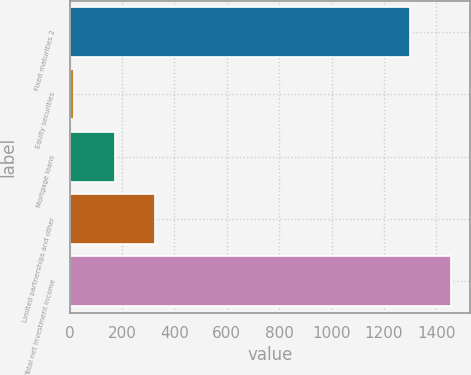<chart> <loc_0><loc_0><loc_500><loc_500><bar_chart><fcel>Fixed maturities 2<fcel>Equity securities<fcel>Mortgage loans<fcel>Limited partnerships and other<fcel>Total net investment income<nl><fcel>1301<fcel>17<fcel>171.4<fcel>325.8<fcel>1455.4<nl></chart> 